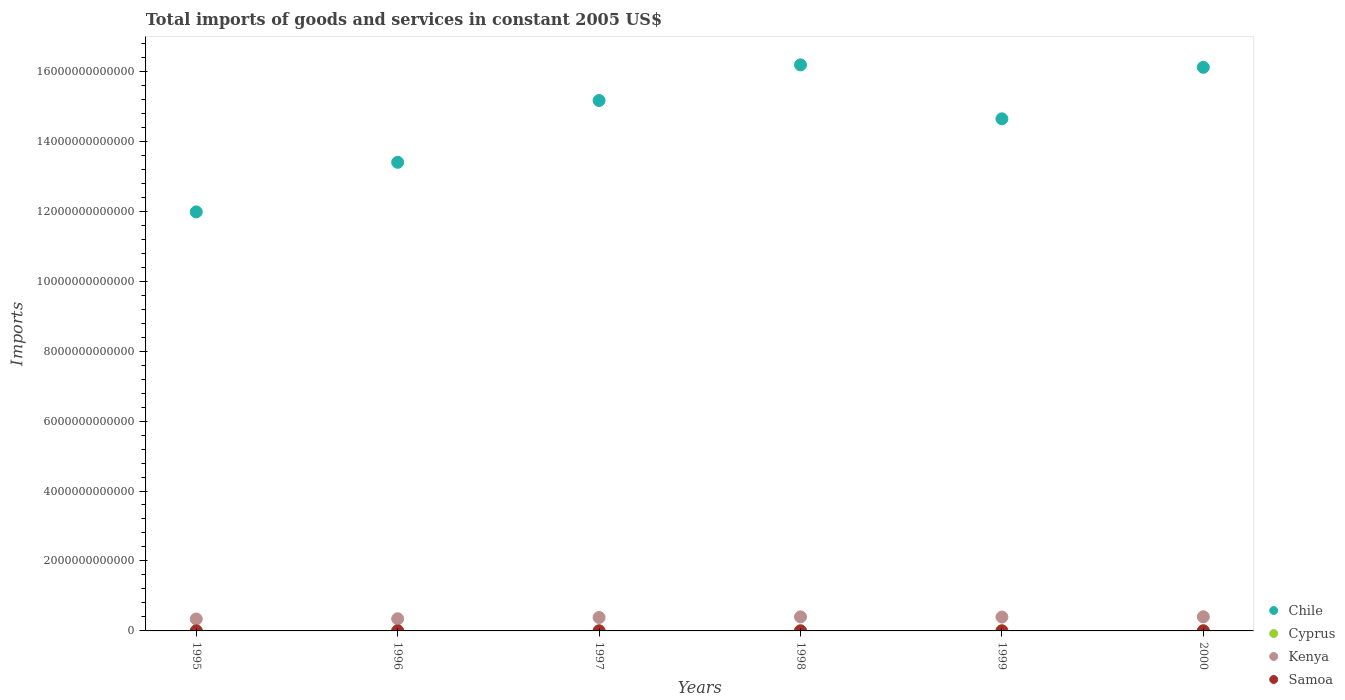How many different coloured dotlines are there?
Your response must be concise. 4. Is the number of dotlines equal to the number of legend labels?
Offer a terse response. Yes. What is the total imports of goods and services in Kenya in 1995?
Your response must be concise. 3.41e+11. Across all years, what is the maximum total imports of goods and services in Cyprus?
Offer a terse response. 7.79e+09. Across all years, what is the minimum total imports of goods and services in Cyprus?
Your response must be concise. 6.53e+09. What is the total total imports of goods and services in Cyprus in the graph?
Provide a short and direct response. 4.22e+1. What is the difference between the total imports of goods and services in Chile in 1996 and that in 2000?
Your answer should be compact. -2.72e+12. What is the difference between the total imports of goods and services in Cyprus in 1999 and the total imports of goods and services in Chile in 2000?
Offer a terse response. -1.61e+13. What is the average total imports of goods and services in Chile per year?
Give a very brief answer. 1.46e+13. In the year 1995, what is the difference between the total imports of goods and services in Cyprus and total imports of goods and services in Chile?
Offer a terse response. -1.20e+13. What is the ratio of the total imports of goods and services in Kenya in 1997 to that in 1999?
Keep it short and to the point. 0.97. Is the difference between the total imports of goods and services in Cyprus in 1996 and 2000 greater than the difference between the total imports of goods and services in Chile in 1996 and 2000?
Make the answer very short. Yes. What is the difference between the highest and the second highest total imports of goods and services in Cyprus?
Offer a terse response. 6.57e+08. What is the difference between the highest and the lowest total imports of goods and services in Kenya?
Provide a short and direct response. 6.26e+1. In how many years, is the total imports of goods and services in Kenya greater than the average total imports of goods and services in Kenya taken over all years?
Provide a succinct answer. 4. Is it the case that in every year, the sum of the total imports of goods and services in Chile and total imports of goods and services in Kenya  is greater than the sum of total imports of goods and services in Samoa and total imports of goods and services in Cyprus?
Offer a very short reply. No. Is the total imports of goods and services in Chile strictly greater than the total imports of goods and services in Kenya over the years?
Your answer should be compact. Yes. How many years are there in the graph?
Provide a short and direct response. 6. What is the difference between two consecutive major ticks on the Y-axis?
Provide a short and direct response. 2.00e+12. Does the graph contain any zero values?
Your answer should be very brief. No. What is the title of the graph?
Your answer should be compact. Total imports of goods and services in constant 2005 US$. Does "Uzbekistan" appear as one of the legend labels in the graph?
Make the answer very short. No. What is the label or title of the X-axis?
Your answer should be very brief. Years. What is the label or title of the Y-axis?
Make the answer very short. Imports. What is the Imports of Chile in 1995?
Offer a very short reply. 1.20e+13. What is the Imports of Cyprus in 1995?
Offer a very short reply. 6.53e+09. What is the Imports in Kenya in 1995?
Your response must be concise. 3.41e+11. What is the Imports of Samoa in 1995?
Give a very brief answer. 3.54e+08. What is the Imports in Chile in 1996?
Your answer should be compact. 1.34e+13. What is the Imports in Cyprus in 1996?
Provide a short and direct response. 6.84e+09. What is the Imports of Kenya in 1996?
Your response must be concise. 3.48e+11. What is the Imports of Samoa in 1996?
Give a very brief answer. 3.75e+08. What is the Imports of Chile in 1997?
Offer a very short reply. 1.52e+13. What is the Imports of Cyprus in 1997?
Provide a succinct answer. 6.93e+09. What is the Imports of Kenya in 1997?
Your answer should be compact. 3.84e+11. What is the Imports of Samoa in 1997?
Give a very brief answer. 3.98e+08. What is the Imports in Chile in 1998?
Make the answer very short. 1.62e+13. What is the Imports of Cyprus in 1998?
Ensure brevity in your answer.  6.96e+09. What is the Imports of Kenya in 1998?
Your response must be concise. 4.02e+11. What is the Imports in Samoa in 1998?
Ensure brevity in your answer.  4.44e+08. What is the Imports of Chile in 1999?
Give a very brief answer. 1.46e+13. What is the Imports in Cyprus in 1999?
Ensure brevity in your answer.  7.13e+09. What is the Imports in Kenya in 1999?
Offer a very short reply. 3.96e+11. What is the Imports in Samoa in 1999?
Give a very brief answer. 5.14e+08. What is the Imports of Chile in 2000?
Offer a terse response. 1.61e+13. What is the Imports of Cyprus in 2000?
Your response must be concise. 7.79e+09. What is the Imports of Kenya in 2000?
Keep it short and to the point. 4.04e+11. What is the Imports in Samoa in 2000?
Your response must be concise. 4.40e+08. Across all years, what is the maximum Imports of Chile?
Keep it short and to the point. 1.62e+13. Across all years, what is the maximum Imports in Cyprus?
Make the answer very short. 7.79e+09. Across all years, what is the maximum Imports of Kenya?
Offer a very short reply. 4.04e+11. Across all years, what is the maximum Imports of Samoa?
Your answer should be very brief. 5.14e+08. Across all years, what is the minimum Imports in Chile?
Your answer should be very brief. 1.20e+13. Across all years, what is the minimum Imports in Cyprus?
Your response must be concise. 6.53e+09. Across all years, what is the minimum Imports of Kenya?
Provide a succinct answer. 3.41e+11. Across all years, what is the minimum Imports in Samoa?
Make the answer very short. 3.54e+08. What is the total Imports of Chile in the graph?
Your answer should be compact. 8.75e+13. What is the total Imports in Cyprus in the graph?
Offer a terse response. 4.22e+1. What is the total Imports in Kenya in the graph?
Make the answer very short. 2.28e+12. What is the total Imports of Samoa in the graph?
Keep it short and to the point. 2.52e+09. What is the difference between the Imports of Chile in 1995 and that in 1996?
Ensure brevity in your answer.  -1.42e+12. What is the difference between the Imports of Cyprus in 1995 and that in 1996?
Give a very brief answer. -3.12e+08. What is the difference between the Imports of Kenya in 1995 and that in 1996?
Keep it short and to the point. -6.22e+09. What is the difference between the Imports of Samoa in 1995 and that in 1996?
Your answer should be compact. -2.11e+07. What is the difference between the Imports of Chile in 1995 and that in 1997?
Your answer should be very brief. -3.18e+12. What is the difference between the Imports of Cyprus in 1995 and that in 1997?
Keep it short and to the point. -3.96e+08. What is the difference between the Imports of Kenya in 1995 and that in 1997?
Offer a terse response. -4.29e+1. What is the difference between the Imports of Samoa in 1995 and that in 1997?
Offer a very short reply. -4.42e+07. What is the difference between the Imports in Chile in 1995 and that in 1998?
Offer a terse response. -4.20e+12. What is the difference between the Imports in Cyprus in 1995 and that in 1998?
Give a very brief answer. -4.33e+08. What is the difference between the Imports of Kenya in 1995 and that in 1998?
Your response must be concise. -6.09e+1. What is the difference between the Imports in Samoa in 1995 and that in 1998?
Your answer should be compact. -8.99e+07. What is the difference between the Imports in Chile in 1995 and that in 1999?
Provide a short and direct response. -2.66e+12. What is the difference between the Imports in Cyprus in 1995 and that in 1999?
Make the answer very short. -6.02e+08. What is the difference between the Imports of Kenya in 1995 and that in 1999?
Make the answer very short. -5.50e+1. What is the difference between the Imports in Samoa in 1995 and that in 1999?
Offer a very short reply. -1.60e+08. What is the difference between the Imports of Chile in 1995 and that in 2000?
Offer a terse response. -4.13e+12. What is the difference between the Imports in Cyprus in 1995 and that in 2000?
Your answer should be compact. -1.26e+09. What is the difference between the Imports in Kenya in 1995 and that in 2000?
Your answer should be very brief. -6.26e+1. What is the difference between the Imports in Samoa in 1995 and that in 2000?
Provide a succinct answer. -8.62e+07. What is the difference between the Imports in Chile in 1996 and that in 1997?
Your response must be concise. -1.77e+12. What is the difference between the Imports of Cyprus in 1996 and that in 1997?
Provide a short and direct response. -8.42e+07. What is the difference between the Imports in Kenya in 1996 and that in 1997?
Offer a very short reply. -3.67e+1. What is the difference between the Imports in Samoa in 1996 and that in 1997?
Your answer should be very brief. -2.32e+07. What is the difference between the Imports of Chile in 1996 and that in 1998?
Offer a terse response. -2.79e+12. What is the difference between the Imports in Cyprus in 1996 and that in 1998?
Your answer should be compact. -1.21e+08. What is the difference between the Imports in Kenya in 1996 and that in 1998?
Give a very brief answer. -5.47e+1. What is the difference between the Imports in Samoa in 1996 and that in 1998?
Ensure brevity in your answer.  -6.88e+07. What is the difference between the Imports of Chile in 1996 and that in 1999?
Provide a short and direct response. -1.24e+12. What is the difference between the Imports in Cyprus in 1996 and that in 1999?
Make the answer very short. -2.90e+08. What is the difference between the Imports in Kenya in 1996 and that in 1999?
Keep it short and to the point. -4.87e+1. What is the difference between the Imports of Samoa in 1996 and that in 1999?
Your answer should be very brief. -1.39e+08. What is the difference between the Imports of Chile in 1996 and that in 2000?
Give a very brief answer. -2.72e+12. What is the difference between the Imports of Cyprus in 1996 and that in 2000?
Give a very brief answer. -9.48e+08. What is the difference between the Imports in Kenya in 1996 and that in 2000?
Ensure brevity in your answer.  -5.63e+1. What is the difference between the Imports of Samoa in 1996 and that in 2000?
Give a very brief answer. -6.52e+07. What is the difference between the Imports in Chile in 1997 and that in 1998?
Keep it short and to the point. -1.02e+12. What is the difference between the Imports in Cyprus in 1997 and that in 1998?
Keep it short and to the point. -3.70e+07. What is the difference between the Imports in Kenya in 1997 and that in 1998?
Provide a succinct answer. -1.80e+1. What is the difference between the Imports in Samoa in 1997 and that in 1998?
Your answer should be very brief. -4.57e+07. What is the difference between the Imports of Chile in 1997 and that in 1999?
Your response must be concise. 5.23e+11. What is the difference between the Imports in Cyprus in 1997 and that in 1999?
Give a very brief answer. -2.06e+08. What is the difference between the Imports in Kenya in 1997 and that in 1999?
Make the answer very short. -1.20e+1. What is the difference between the Imports of Samoa in 1997 and that in 1999?
Keep it short and to the point. -1.16e+08. What is the difference between the Imports in Chile in 1997 and that in 2000?
Ensure brevity in your answer.  -9.49e+11. What is the difference between the Imports in Cyprus in 1997 and that in 2000?
Your answer should be compact. -8.63e+08. What is the difference between the Imports in Kenya in 1997 and that in 2000?
Give a very brief answer. -1.96e+1. What is the difference between the Imports in Samoa in 1997 and that in 2000?
Give a very brief answer. -4.20e+07. What is the difference between the Imports in Chile in 1998 and that in 1999?
Provide a succinct answer. 1.54e+12. What is the difference between the Imports in Cyprus in 1998 and that in 1999?
Offer a very short reply. -1.69e+08. What is the difference between the Imports in Kenya in 1998 and that in 1999?
Keep it short and to the point. 5.95e+09. What is the difference between the Imports of Samoa in 1998 and that in 1999?
Offer a very short reply. -7.04e+07. What is the difference between the Imports in Chile in 1998 and that in 2000?
Ensure brevity in your answer.  7.03e+1. What is the difference between the Imports of Cyprus in 1998 and that in 2000?
Ensure brevity in your answer.  -8.26e+08. What is the difference between the Imports in Kenya in 1998 and that in 2000?
Your response must be concise. -1.65e+09. What is the difference between the Imports in Samoa in 1998 and that in 2000?
Make the answer very short. 3.66e+06. What is the difference between the Imports of Chile in 1999 and that in 2000?
Provide a short and direct response. -1.47e+12. What is the difference between the Imports in Cyprus in 1999 and that in 2000?
Offer a very short reply. -6.57e+08. What is the difference between the Imports in Kenya in 1999 and that in 2000?
Your answer should be compact. -7.61e+09. What is the difference between the Imports of Samoa in 1999 and that in 2000?
Keep it short and to the point. 7.40e+07. What is the difference between the Imports of Chile in 1995 and the Imports of Cyprus in 1996?
Offer a terse response. 1.20e+13. What is the difference between the Imports in Chile in 1995 and the Imports in Kenya in 1996?
Make the answer very short. 1.16e+13. What is the difference between the Imports of Chile in 1995 and the Imports of Samoa in 1996?
Make the answer very short. 1.20e+13. What is the difference between the Imports in Cyprus in 1995 and the Imports in Kenya in 1996?
Give a very brief answer. -3.41e+11. What is the difference between the Imports in Cyprus in 1995 and the Imports in Samoa in 1996?
Provide a short and direct response. 6.16e+09. What is the difference between the Imports of Kenya in 1995 and the Imports of Samoa in 1996?
Provide a short and direct response. 3.41e+11. What is the difference between the Imports in Chile in 1995 and the Imports in Cyprus in 1997?
Your response must be concise. 1.20e+13. What is the difference between the Imports of Chile in 1995 and the Imports of Kenya in 1997?
Your response must be concise. 1.16e+13. What is the difference between the Imports in Chile in 1995 and the Imports in Samoa in 1997?
Provide a short and direct response. 1.20e+13. What is the difference between the Imports of Cyprus in 1995 and the Imports of Kenya in 1997?
Offer a terse response. -3.78e+11. What is the difference between the Imports in Cyprus in 1995 and the Imports in Samoa in 1997?
Your answer should be compact. 6.13e+09. What is the difference between the Imports in Kenya in 1995 and the Imports in Samoa in 1997?
Your answer should be very brief. 3.41e+11. What is the difference between the Imports in Chile in 1995 and the Imports in Cyprus in 1998?
Your answer should be compact. 1.20e+13. What is the difference between the Imports of Chile in 1995 and the Imports of Kenya in 1998?
Your response must be concise. 1.16e+13. What is the difference between the Imports in Chile in 1995 and the Imports in Samoa in 1998?
Keep it short and to the point. 1.20e+13. What is the difference between the Imports in Cyprus in 1995 and the Imports in Kenya in 1998?
Provide a short and direct response. -3.96e+11. What is the difference between the Imports in Cyprus in 1995 and the Imports in Samoa in 1998?
Provide a short and direct response. 6.09e+09. What is the difference between the Imports of Kenya in 1995 and the Imports of Samoa in 1998?
Give a very brief answer. 3.41e+11. What is the difference between the Imports in Chile in 1995 and the Imports in Cyprus in 1999?
Ensure brevity in your answer.  1.20e+13. What is the difference between the Imports in Chile in 1995 and the Imports in Kenya in 1999?
Make the answer very short. 1.16e+13. What is the difference between the Imports in Chile in 1995 and the Imports in Samoa in 1999?
Your answer should be very brief. 1.20e+13. What is the difference between the Imports of Cyprus in 1995 and the Imports of Kenya in 1999?
Your response must be concise. -3.90e+11. What is the difference between the Imports in Cyprus in 1995 and the Imports in Samoa in 1999?
Your answer should be compact. 6.02e+09. What is the difference between the Imports of Kenya in 1995 and the Imports of Samoa in 1999?
Your answer should be compact. 3.41e+11. What is the difference between the Imports in Chile in 1995 and the Imports in Cyprus in 2000?
Ensure brevity in your answer.  1.20e+13. What is the difference between the Imports of Chile in 1995 and the Imports of Kenya in 2000?
Your answer should be compact. 1.16e+13. What is the difference between the Imports of Chile in 1995 and the Imports of Samoa in 2000?
Your response must be concise. 1.20e+13. What is the difference between the Imports of Cyprus in 1995 and the Imports of Kenya in 2000?
Provide a succinct answer. -3.98e+11. What is the difference between the Imports in Cyprus in 1995 and the Imports in Samoa in 2000?
Provide a succinct answer. 6.09e+09. What is the difference between the Imports in Kenya in 1995 and the Imports in Samoa in 2000?
Your answer should be compact. 3.41e+11. What is the difference between the Imports of Chile in 1996 and the Imports of Cyprus in 1997?
Your answer should be compact. 1.34e+13. What is the difference between the Imports in Chile in 1996 and the Imports in Kenya in 1997?
Offer a very short reply. 1.30e+13. What is the difference between the Imports of Chile in 1996 and the Imports of Samoa in 1997?
Your answer should be very brief. 1.34e+13. What is the difference between the Imports in Cyprus in 1996 and the Imports in Kenya in 1997?
Offer a terse response. -3.78e+11. What is the difference between the Imports of Cyprus in 1996 and the Imports of Samoa in 1997?
Your answer should be compact. 6.44e+09. What is the difference between the Imports of Kenya in 1996 and the Imports of Samoa in 1997?
Make the answer very short. 3.47e+11. What is the difference between the Imports in Chile in 1996 and the Imports in Cyprus in 1998?
Provide a short and direct response. 1.34e+13. What is the difference between the Imports in Chile in 1996 and the Imports in Kenya in 1998?
Your answer should be very brief. 1.30e+13. What is the difference between the Imports of Chile in 1996 and the Imports of Samoa in 1998?
Your response must be concise. 1.34e+13. What is the difference between the Imports of Cyprus in 1996 and the Imports of Kenya in 1998?
Provide a short and direct response. -3.96e+11. What is the difference between the Imports of Cyprus in 1996 and the Imports of Samoa in 1998?
Make the answer very short. 6.40e+09. What is the difference between the Imports in Kenya in 1996 and the Imports in Samoa in 1998?
Offer a very short reply. 3.47e+11. What is the difference between the Imports of Chile in 1996 and the Imports of Cyprus in 1999?
Your response must be concise. 1.34e+13. What is the difference between the Imports of Chile in 1996 and the Imports of Kenya in 1999?
Provide a short and direct response. 1.30e+13. What is the difference between the Imports in Chile in 1996 and the Imports in Samoa in 1999?
Provide a short and direct response. 1.34e+13. What is the difference between the Imports in Cyprus in 1996 and the Imports in Kenya in 1999?
Offer a very short reply. -3.90e+11. What is the difference between the Imports of Cyprus in 1996 and the Imports of Samoa in 1999?
Your response must be concise. 6.33e+09. What is the difference between the Imports of Kenya in 1996 and the Imports of Samoa in 1999?
Keep it short and to the point. 3.47e+11. What is the difference between the Imports in Chile in 1996 and the Imports in Cyprus in 2000?
Keep it short and to the point. 1.34e+13. What is the difference between the Imports of Chile in 1996 and the Imports of Kenya in 2000?
Give a very brief answer. 1.30e+13. What is the difference between the Imports in Chile in 1996 and the Imports in Samoa in 2000?
Make the answer very short. 1.34e+13. What is the difference between the Imports of Cyprus in 1996 and the Imports of Kenya in 2000?
Offer a very short reply. -3.97e+11. What is the difference between the Imports in Cyprus in 1996 and the Imports in Samoa in 2000?
Your answer should be compact. 6.40e+09. What is the difference between the Imports of Kenya in 1996 and the Imports of Samoa in 2000?
Provide a succinct answer. 3.47e+11. What is the difference between the Imports of Chile in 1997 and the Imports of Cyprus in 1998?
Offer a very short reply. 1.52e+13. What is the difference between the Imports of Chile in 1997 and the Imports of Kenya in 1998?
Keep it short and to the point. 1.48e+13. What is the difference between the Imports in Chile in 1997 and the Imports in Samoa in 1998?
Your answer should be very brief. 1.52e+13. What is the difference between the Imports in Cyprus in 1997 and the Imports in Kenya in 1998?
Offer a terse response. -3.95e+11. What is the difference between the Imports in Cyprus in 1997 and the Imports in Samoa in 1998?
Give a very brief answer. 6.48e+09. What is the difference between the Imports in Kenya in 1997 and the Imports in Samoa in 1998?
Your answer should be compact. 3.84e+11. What is the difference between the Imports of Chile in 1997 and the Imports of Cyprus in 1999?
Your answer should be compact. 1.52e+13. What is the difference between the Imports of Chile in 1997 and the Imports of Kenya in 1999?
Provide a short and direct response. 1.48e+13. What is the difference between the Imports of Chile in 1997 and the Imports of Samoa in 1999?
Keep it short and to the point. 1.52e+13. What is the difference between the Imports in Cyprus in 1997 and the Imports in Kenya in 1999?
Offer a very short reply. -3.90e+11. What is the difference between the Imports in Cyprus in 1997 and the Imports in Samoa in 1999?
Provide a succinct answer. 6.41e+09. What is the difference between the Imports of Kenya in 1997 and the Imports of Samoa in 1999?
Provide a short and direct response. 3.84e+11. What is the difference between the Imports in Chile in 1997 and the Imports in Cyprus in 2000?
Make the answer very short. 1.52e+13. What is the difference between the Imports in Chile in 1997 and the Imports in Kenya in 2000?
Ensure brevity in your answer.  1.48e+13. What is the difference between the Imports of Chile in 1997 and the Imports of Samoa in 2000?
Your answer should be compact. 1.52e+13. What is the difference between the Imports of Cyprus in 1997 and the Imports of Kenya in 2000?
Provide a succinct answer. -3.97e+11. What is the difference between the Imports of Cyprus in 1997 and the Imports of Samoa in 2000?
Offer a terse response. 6.49e+09. What is the difference between the Imports in Kenya in 1997 and the Imports in Samoa in 2000?
Your answer should be very brief. 3.84e+11. What is the difference between the Imports in Chile in 1998 and the Imports in Cyprus in 1999?
Offer a terse response. 1.62e+13. What is the difference between the Imports of Chile in 1998 and the Imports of Kenya in 1999?
Offer a terse response. 1.58e+13. What is the difference between the Imports of Chile in 1998 and the Imports of Samoa in 1999?
Keep it short and to the point. 1.62e+13. What is the difference between the Imports of Cyprus in 1998 and the Imports of Kenya in 1999?
Offer a terse response. -3.89e+11. What is the difference between the Imports in Cyprus in 1998 and the Imports in Samoa in 1999?
Offer a very short reply. 6.45e+09. What is the difference between the Imports of Kenya in 1998 and the Imports of Samoa in 1999?
Keep it short and to the point. 4.02e+11. What is the difference between the Imports in Chile in 1998 and the Imports in Cyprus in 2000?
Your answer should be compact. 1.62e+13. What is the difference between the Imports in Chile in 1998 and the Imports in Kenya in 2000?
Provide a succinct answer. 1.58e+13. What is the difference between the Imports in Chile in 1998 and the Imports in Samoa in 2000?
Provide a succinct answer. 1.62e+13. What is the difference between the Imports in Cyprus in 1998 and the Imports in Kenya in 2000?
Ensure brevity in your answer.  -3.97e+11. What is the difference between the Imports of Cyprus in 1998 and the Imports of Samoa in 2000?
Provide a short and direct response. 6.52e+09. What is the difference between the Imports of Kenya in 1998 and the Imports of Samoa in 2000?
Provide a succinct answer. 4.02e+11. What is the difference between the Imports of Chile in 1999 and the Imports of Cyprus in 2000?
Give a very brief answer. 1.46e+13. What is the difference between the Imports of Chile in 1999 and the Imports of Kenya in 2000?
Offer a terse response. 1.42e+13. What is the difference between the Imports in Chile in 1999 and the Imports in Samoa in 2000?
Provide a succinct answer. 1.46e+13. What is the difference between the Imports of Cyprus in 1999 and the Imports of Kenya in 2000?
Offer a very short reply. -3.97e+11. What is the difference between the Imports of Cyprus in 1999 and the Imports of Samoa in 2000?
Your answer should be compact. 6.69e+09. What is the difference between the Imports of Kenya in 1999 and the Imports of Samoa in 2000?
Make the answer very short. 3.96e+11. What is the average Imports in Chile per year?
Offer a very short reply. 1.46e+13. What is the average Imports of Cyprus per year?
Give a very brief answer. 7.03e+09. What is the average Imports of Kenya per year?
Keep it short and to the point. 3.79e+11. What is the average Imports in Samoa per year?
Offer a terse response. 4.21e+08. In the year 1995, what is the difference between the Imports in Chile and Imports in Cyprus?
Ensure brevity in your answer.  1.20e+13. In the year 1995, what is the difference between the Imports of Chile and Imports of Kenya?
Ensure brevity in your answer.  1.16e+13. In the year 1995, what is the difference between the Imports in Chile and Imports in Samoa?
Your answer should be very brief. 1.20e+13. In the year 1995, what is the difference between the Imports in Cyprus and Imports in Kenya?
Offer a very short reply. -3.35e+11. In the year 1995, what is the difference between the Imports in Cyprus and Imports in Samoa?
Your response must be concise. 6.18e+09. In the year 1995, what is the difference between the Imports of Kenya and Imports of Samoa?
Provide a short and direct response. 3.41e+11. In the year 1996, what is the difference between the Imports in Chile and Imports in Cyprus?
Ensure brevity in your answer.  1.34e+13. In the year 1996, what is the difference between the Imports in Chile and Imports in Kenya?
Provide a short and direct response. 1.30e+13. In the year 1996, what is the difference between the Imports of Chile and Imports of Samoa?
Make the answer very short. 1.34e+13. In the year 1996, what is the difference between the Imports of Cyprus and Imports of Kenya?
Ensure brevity in your answer.  -3.41e+11. In the year 1996, what is the difference between the Imports in Cyprus and Imports in Samoa?
Your answer should be very brief. 6.47e+09. In the year 1996, what is the difference between the Imports in Kenya and Imports in Samoa?
Keep it short and to the point. 3.47e+11. In the year 1997, what is the difference between the Imports of Chile and Imports of Cyprus?
Provide a succinct answer. 1.52e+13. In the year 1997, what is the difference between the Imports of Chile and Imports of Kenya?
Offer a very short reply. 1.48e+13. In the year 1997, what is the difference between the Imports of Chile and Imports of Samoa?
Give a very brief answer. 1.52e+13. In the year 1997, what is the difference between the Imports of Cyprus and Imports of Kenya?
Provide a succinct answer. -3.77e+11. In the year 1997, what is the difference between the Imports of Cyprus and Imports of Samoa?
Your answer should be compact. 6.53e+09. In the year 1997, what is the difference between the Imports in Kenya and Imports in Samoa?
Offer a terse response. 3.84e+11. In the year 1998, what is the difference between the Imports in Chile and Imports in Cyprus?
Keep it short and to the point. 1.62e+13. In the year 1998, what is the difference between the Imports in Chile and Imports in Kenya?
Provide a short and direct response. 1.58e+13. In the year 1998, what is the difference between the Imports of Chile and Imports of Samoa?
Provide a short and direct response. 1.62e+13. In the year 1998, what is the difference between the Imports in Cyprus and Imports in Kenya?
Make the answer very short. -3.95e+11. In the year 1998, what is the difference between the Imports of Cyprus and Imports of Samoa?
Your answer should be very brief. 6.52e+09. In the year 1998, what is the difference between the Imports of Kenya and Imports of Samoa?
Make the answer very short. 4.02e+11. In the year 1999, what is the difference between the Imports of Chile and Imports of Cyprus?
Give a very brief answer. 1.46e+13. In the year 1999, what is the difference between the Imports of Chile and Imports of Kenya?
Provide a short and direct response. 1.42e+13. In the year 1999, what is the difference between the Imports of Chile and Imports of Samoa?
Your response must be concise. 1.46e+13. In the year 1999, what is the difference between the Imports of Cyprus and Imports of Kenya?
Keep it short and to the point. -3.89e+11. In the year 1999, what is the difference between the Imports in Cyprus and Imports in Samoa?
Your response must be concise. 6.62e+09. In the year 1999, what is the difference between the Imports in Kenya and Imports in Samoa?
Your answer should be very brief. 3.96e+11. In the year 2000, what is the difference between the Imports of Chile and Imports of Cyprus?
Offer a terse response. 1.61e+13. In the year 2000, what is the difference between the Imports in Chile and Imports in Kenya?
Provide a succinct answer. 1.57e+13. In the year 2000, what is the difference between the Imports of Chile and Imports of Samoa?
Make the answer very short. 1.61e+13. In the year 2000, what is the difference between the Imports of Cyprus and Imports of Kenya?
Offer a very short reply. -3.96e+11. In the year 2000, what is the difference between the Imports of Cyprus and Imports of Samoa?
Provide a succinct answer. 7.35e+09. In the year 2000, what is the difference between the Imports in Kenya and Imports in Samoa?
Your answer should be compact. 4.04e+11. What is the ratio of the Imports in Chile in 1995 to that in 1996?
Ensure brevity in your answer.  0.89. What is the ratio of the Imports in Cyprus in 1995 to that in 1996?
Keep it short and to the point. 0.95. What is the ratio of the Imports in Kenya in 1995 to that in 1996?
Make the answer very short. 0.98. What is the ratio of the Imports of Samoa in 1995 to that in 1996?
Make the answer very short. 0.94. What is the ratio of the Imports in Chile in 1995 to that in 1997?
Ensure brevity in your answer.  0.79. What is the ratio of the Imports in Cyprus in 1995 to that in 1997?
Provide a succinct answer. 0.94. What is the ratio of the Imports of Kenya in 1995 to that in 1997?
Provide a succinct answer. 0.89. What is the ratio of the Imports in Samoa in 1995 to that in 1997?
Give a very brief answer. 0.89. What is the ratio of the Imports in Chile in 1995 to that in 1998?
Your answer should be very brief. 0.74. What is the ratio of the Imports of Cyprus in 1995 to that in 1998?
Offer a terse response. 0.94. What is the ratio of the Imports in Kenya in 1995 to that in 1998?
Keep it short and to the point. 0.85. What is the ratio of the Imports in Samoa in 1995 to that in 1998?
Provide a succinct answer. 0.8. What is the ratio of the Imports of Chile in 1995 to that in 1999?
Make the answer very short. 0.82. What is the ratio of the Imports in Cyprus in 1995 to that in 1999?
Keep it short and to the point. 0.92. What is the ratio of the Imports of Kenya in 1995 to that in 1999?
Give a very brief answer. 0.86. What is the ratio of the Imports in Samoa in 1995 to that in 1999?
Keep it short and to the point. 0.69. What is the ratio of the Imports in Chile in 1995 to that in 2000?
Offer a very short reply. 0.74. What is the ratio of the Imports in Cyprus in 1995 to that in 2000?
Offer a terse response. 0.84. What is the ratio of the Imports of Kenya in 1995 to that in 2000?
Provide a short and direct response. 0.85. What is the ratio of the Imports in Samoa in 1995 to that in 2000?
Your answer should be compact. 0.8. What is the ratio of the Imports of Chile in 1996 to that in 1997?
Offer a terse response. 0.88. What is the ratio of the Imports of Kenya in 1996 to that in 1997?
Provide a short and direct response. 0.9. What is the ratio of the Imports of Samoa in 1996 to that in 1997?
Your answer should be very brief. 0.94. What is the ratio of the Imports of Chile in 1996 to that in 1998?
Your answer should be very brief. 0.83. What is the ratio of the Imports in Cyprus in 1996 to that in 1998?
Make the answer very short. 0.98. What is the ratio of the Imports of Kenya in 1996 to that in 1998?
Your answer should be very brief. 0.86. What is the ratio of the Imports of Samoa in 1996 to that in 1998?
Your answer should be very brief. 0.84. What is the ratio of the Imports in Chile in 1996 to that in 1999?
Make the answer very short. 0.92. What is the ratio of the Imports of Cyprus in 1996 to that in 1999?
Make the answer very short. 0.96. What is the ratio of the Imports in Kenya in 1996 to that in 1999?
Provide a succinct answer. 0.88. What is the ratio of the Imports in Samoa in 1996 to that in 1999?
Ensure brevity in your answer.  0.73. What is the ratio of the Imports in Chile in 1996 to that in 2000?
Your response must be concise. 0.83. What is the ratio of the Imports in Cyprus in 1996 to that in 2000?
Provide a succinct answer. 0.88. What is the ratio of the Imports in Kenya in 1996 to that in 2000?
Make the answer very short. 0.86. What is the ratio of the Imports of Samoa in 1996 to that in 2000?
Offer a very short reply. 0.85. What is the ratio of the Imports of Chile in 1997 to that in 1998?
Provide a succinct answer. 0.94. What is the ratio of the Imports of Cyprus in 1997 to that in 1998?
Provide a short and direct response. 0.99. What is the ratio of the Imports in Kenya in 1997 to that in 1998?
Your answer should be compact. 0.96. What is the ratio of the Imports of Samoa in 1997 to that in 1998?
Offer a very short reply. 0.9. What is the ratio of the Imports in Chile in 1997 to that in 1999?
Give a very brief answer. 1.04. What is the ratio of the Imports of Cyprus in 1997 to that in 1999?
Your answer should be compact. 0.97. What is the ratio of the Imports of Kenya in 1997 to that in 1999?
Make the answer very short. 0.97. What is the ratio of the Imports in Samoa in 1997 to that in 1999?
Provide a short and direct response. 0.77. What is the ratio of the Imports in Chile in 1997 to that in 2000?
Your answer should be compact. 0.94. What is the ratio of the Imports of Cyprus in 1997 to that in 2000?
Your answer should be compact. 0.89. What is the ratio of the Imports of Kenya in 1997 to that in 2000?
Your answer should be very brief. 0.95. What is the ratio of the Imports of Samoa in 1997 to that in 2000?
Your response must be concise. 0.9. What is the ratio of the Imports in Chile in 1998 to that in 1999?
Your answer should be very brief. 1.11. What is the ratio of the Imports of Cyprus in 1998 to that in 1999?
Offer a terse response. 0.98. What is the ratio of the Imports in Samoa in 1998 to that in 1999?
Your answer should be very brief. 0.86. What is the ratio of the Imports in Chile in 1998 to that in 2000?
Offer a very short reply. 1. What is the ratio of the Imports in Cyprus in 1998 to that in 2000?
Offer a very short reply. 0.89. What is the ratio of the Imports of Samoa in 1998 to that in 2000?
Provide a short and direct response. 1.01. What is the ratio of the Imports of Chile in 1999 to that in 2000?
Give a very brief answer. 0.91. What is the ratio of the Imports in Cyprus in 1999 to that in 2000?
Ensure brevity in your answer.  0.92. What is the ratio of the Imports of Kenya in 1999 to that in 2000?
Offer a very short reply. 0.98. What is the ratio of the Imports of Samoa in 1999 to that in 2000?
Give a very brief answer. 1.17. What is the difference between the highest and the second highest Imports in Chile?
Offer a very short reply. 7.03e+1. What is the difference between the highest and the second highest Imports in Cyprus?
Your answer should be very brief. 6.57e+08. What is the difference between the highest and the second highest Imports of Kenya?
Offer a very short reply. 1.65e+09. What is the difference between the highest and the second highest Imports of Samoa?
Offer a very short reply. 7.04e+07. What is the difference between the highest and the lowest Imports in Chile?
Make the answer very short. 4.20e+12. What is the difference between the highest and the lowest Imports in Cyprus?
Your response must be concise. 1.26e+09. What is the difference between the highest and the lowest Imports of Kenya?
Ensure brevity in your answer.  6.26e+1. What is the difference between the highest and the lowest Imports in Samoa?
Provide a succinct answer. 1.60e+08. 